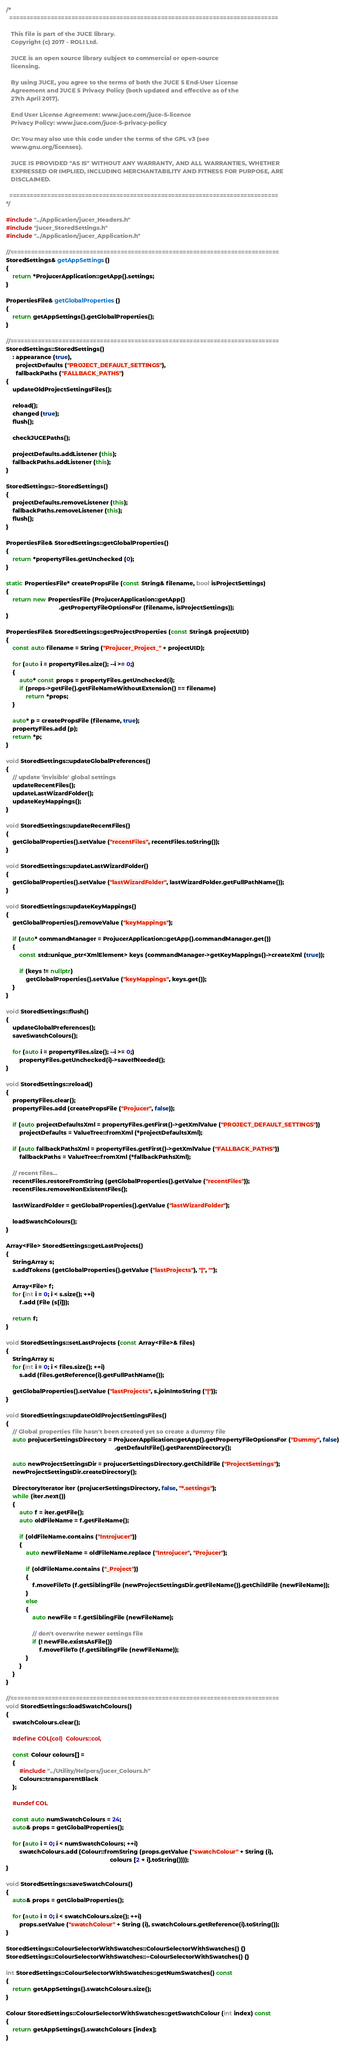<code> <loc_0><loc_0><loc_500><loc_500><_C++_>/*
  ==============================================================================

   This file is part of the JUCE library.
   Copyright (c) 2017 - ROLI Ltd.

   JUCE is an open source library subject to commercial or open-source
   licensing.

   By using JUCE, you agree to the terms of both the JUCE 5 End-User License
   Agreement and JUCE 5 Privacy Policy (both updated and effective as of the
   27th April 2017).

   End User License Agreement: www.juce.com/juce-5-licence
   Privacy Policy: www.juce.com/juce-5-privacy-policy

   Or: You may also use this code under the terms of the GPL v3 (see
   www.gnu.org/licenses).

   JUCE IS PROVIDED "AS IS" WITHOUT ANY WARRANTY, AND ALL WARRANTIES, WHETHER
   EXPRESSED OR IMPLIED, INCLUDING MERCHANTABILITY AND FITNESS FOR PURPOSE, ARE
   DISCLAIMED.

  ==============================================================================
*/

#include "../Application/jucer_Headers.h"
#include "jucer_StoredSettings.h"
#include "../Application/jucer_Application.h"

//==============================================================================
StoredSettings& getAppSettings()
{
    return *ProjucerApplication::getApp().settings;
}

PropertiesFile& getGlobalProperties()
{
    return getAppSettings().getGlobalProperties();
}

//==============================================================================
StoredSettings::StoredSettings()
    : appearance (true),
      projectDefaults ("PROJECT_DEFAULT_SETTINGS"),
      fallbackPaths ("FALLBACK_PATHS")
{
    updateOldProjectSettingsFiles();

    reload();
    changed (true);
    flush();

    checkJUCEPaths();

    projectDefaults.addListener (this);
    fallbackPaths.addListener (this);
}

StoredSettings::~StoredSettings()
{
    projectDefaults.removeListener (this);
    fallbackPaths.removeListener (this);
    flush();
}

PropertiesFile& StoredSettings::getGlobalProperties()
{
    return *propertyFiles.getUnchecked (0);
}

static PropertiesFile* createPropsFile (const String& filename, bool isProjectSettings)
{
    return new PropertiesFile (ProjucerApplication::getApp()
                                .getPropertyFileOptionsFor (filename, isProjectSettings));
}

PropertiesFile& StoredSettings::getProjectProperties (const String& projectUID)
{
    const auto filename = String ("Projucer_Project_" + projectUID);

    for (auto i = propertyFiles.size(); --i >= 0;)
    {
        auto* const props = propertyFiles.getUnchecked(i);
        if (props->getFile().getFileNameWithoutExtension() == filename)
            return *props;
    }

    auto* p = createPropsFile (filename, true);
    propertyFiles.add (p);
    return *p;
}

void StoredSettings::updateGlobalPreferences()
{
    // update 'invisible' global settings
    updateRecentFiles();
    updateLastWizardFolder();
    updateKeyMappings();
}

void StoredSettings::updateRecentFiles()
{
    getGlobalProperties().setValue ("recentFiles", recentFiles.toString());
}

void StoredSettings::updateLastWizardFolder()
{
    getGlobalProperties().setValue ("lastWizardFolder", lastWizardFolder.getFullPathName());
}

void StoredSettings::updateKeyMappings()
{
    getGlobalProperties().removeValue ("keyMappings");

    if (auto* commandManager = ProjucerApplication::getApp().commandManager.get())
    {
        const std::unique_ptr<XmlElement> keys (commandManager->getKeyMappings()->createXml (true));

        if (keys != nullptr)
            getGlobalProperties().setValue ("keyMappings", keys.get());
    }
}

void StoredSettings::flush()
{
    updateGlobalPreferences();
    saveSwatchColours();

    for (auto i = propertyFiles.size(); --i >= 0;)
        propertyFiles.getUnchecked(i)->saveIfNeeded();
}

void StoredSettings::reload()
{
    propertyFiles.clear();
    propertyFiles.add (createPropsFile ("Projucer", false));

    if (auto projectDefaultsXml = propertyFiles.getFirst()->getXmlValue ("PROJECT_DEFAULT_SETTINGS"))
        projectDefaults = ValueTree::fromXml (*projectDefaultsXml);

    if (auto fallbackPathsXml = propertyFiles.getFirst()->getXmlValue ("FALLBACK_PATHS"))
        fallbackPaths = ValueTree::fromXml (*fallbackPathsXml);

    // recent files...
    recentFiles.restoreFromString (getGlobalProperties().getValue ("recentFiles"));
    recentFiles.removeNonExistentFiles();

    lastWizardFolder = getGlobalProperties().getValue ("lastWizardFolder");

    loadSwatchColours();
}

Array<File> StoredSettings::getLastProjects()
{
    StringArray s;
    s.addTokens (getGlobalProperties().getValue ("lastProjects"), "|", "");

    Array<File> f;
    for (int i = 0; i < s.size(); ++i)
        f.add (File (s[i]));

    return f;
}

void StoredSettings::setLastProjects (const Array<File>& files)
{
    StringArray s;
    for (int i = 0; i < files.size(); ++i)
        s.add (files.getReference(i).getFullPathName());

    getGlobalProperties().setValue ("lastProjects", s.joinIntoString ("|"));
}

void StoredSettings::updateOldProjectSettingsFiles()
{
    // Global properties file hasn't been created yet so create a dummy file
    auto projucerSettingsDirectory = ProjucerApplication::getApp().getPropertyFileOptionsFor ("Dummy", false)
                                                                  .getDefaultFile().getParentDirectory();

    auto newProjectSettingsDir = projucerSettingsDirectory.getChildFile ("ProjectSettings");
    newProjectSettingsDir.createDirectory();

    DirectoryIterator iter (projucerSettingsDirectory, false, "*.settings");
    while (iter.next())
    {
        auto f = iter.getFile();
        auto oldFileName = f.getFileName();

        if (oldFileName.contains ("Introjucer"))
        {
            auto newFileName = oldFileName.replace ("Introjucer", "Projucer");

            if (oldFileName.contains ("_Project"))
            {
                f.moveFileTo (f.getSiblingFile (newProjectSettingsDir.getFileName()).getChildFile (newFileName));
            }
            else
            {
                auto newFile = f.getSiblingFile (newFileName);

                // don't overwrite newer settings file
                if (! newFile.existsAsFile())
                    f.moveFileTo (f.getSiblingFile (newFileName));
            }
        }
    }
}

//==============================================================================
void StoredSettings::loadSwatchColours()
{
    swatchColours.clear();

    #define COL(col)  Colours::col,

    const Colour colours[] =
    {
        #include "../Utility/Helpers/jucer_Colours.h"
        Colours::transparentBlack
    };

    #undef COL

    const auto numSwatchColours = 24;
    auto& props = getGlobalProperties();

    for (auto i = 0; i < numSwatchColours; ++i)
        swatchColours.add (Colour::fromString (props.getValue ("swatchColour" + String (i),
                                                               colours [2 + i].toString())));
}

void StoredSettings::saveSwatchColours()
{
    auto& props = getGlobalProperties();

    for (auto i = 0; i < swatchColours.size(); ++i)
        props.setValue ("swatchColour" + String (i), swatchColours.getReference(i).toString());
}

StoredSettings::ColourSelectorWithSwatches::ColourSelectorWithSwatches() {}
StoredSettings::ColourSelectorWithSwatches::~ColourSelectorWithSwatches() {}

int StoredSettings::ColourSelectorWithSwatches::getNumSwatches() const
{
    return getAppSettings().swatchColours.size();
}

Colour StoredSettings::ColourSelectorWithSwatches::getSwatchColour (int index) const
{
    return getAppSettings().swatchColours [index];
}
</code> 